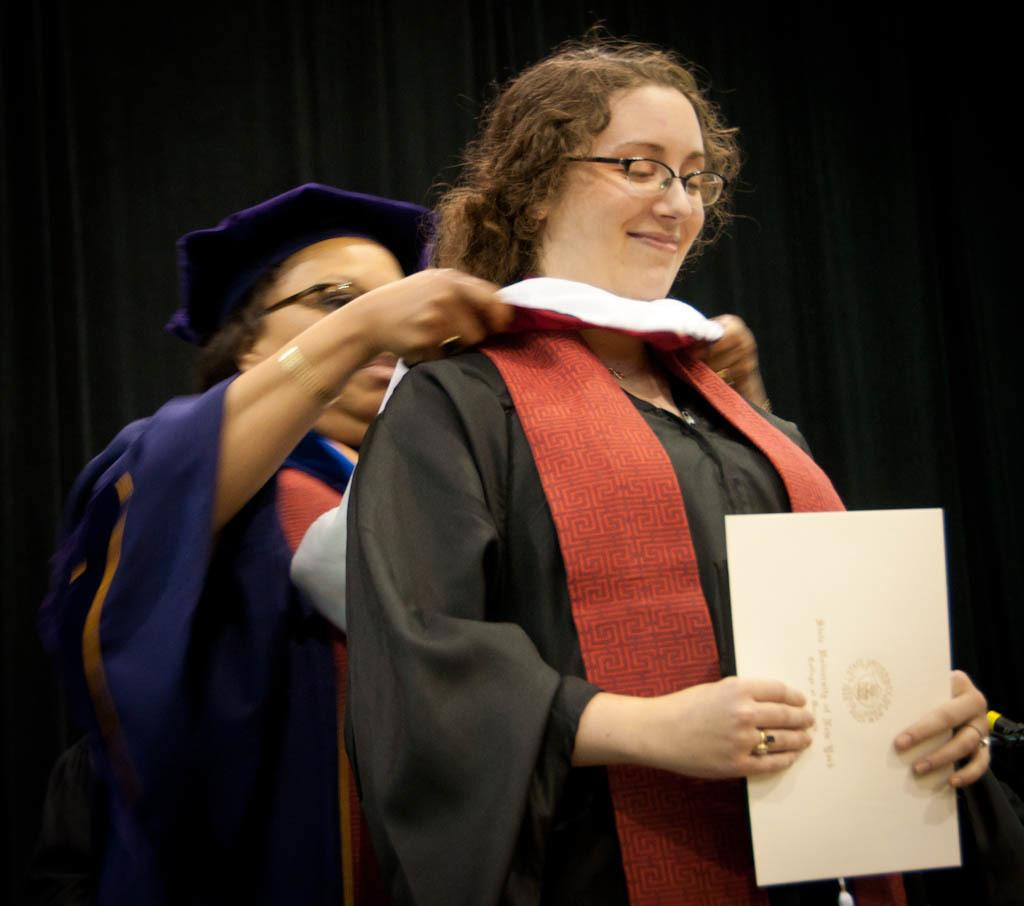How many people are present in the image? There are two people standing in the image. What is the woman holding in the image? The woman is holding a card in the image. Can you describe the woman's appearance? The woman is wearing spectacles and is smiling. What is the color of the background in the image? The background of the image is dark. What type of disease is the governor treating in the image? There is no governor present in the image, and therefore no disease treatment can be observed. 